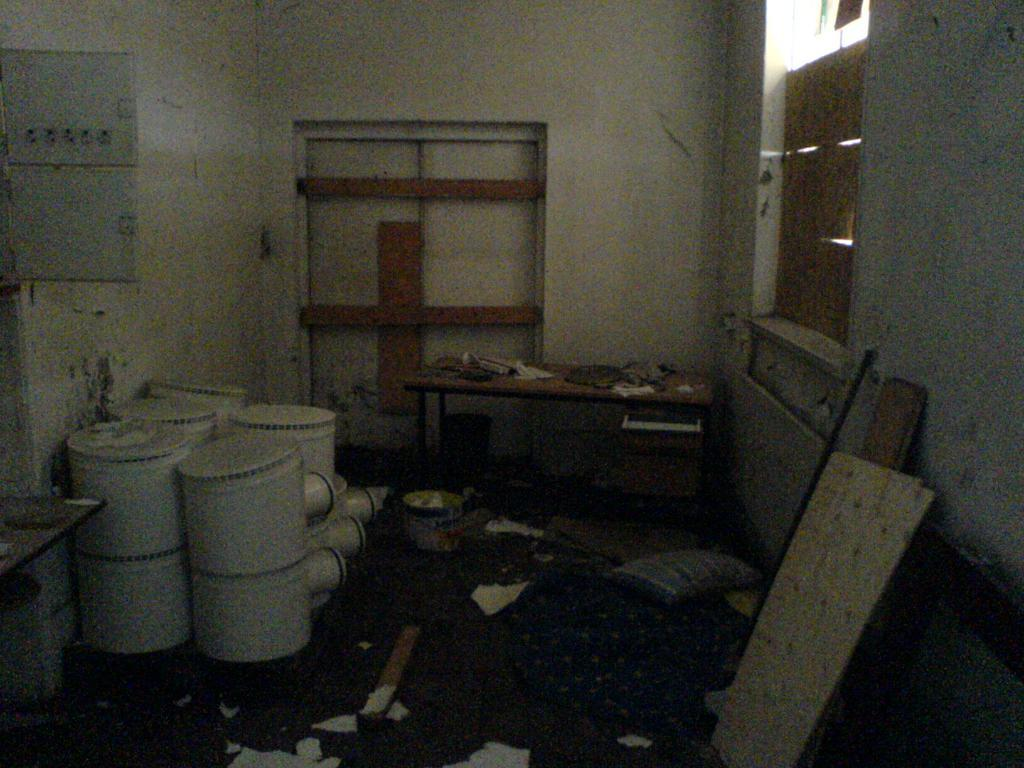What type of objects can be seen stacked in the image? There are boxes in the image. What type of furniture is present in the image? There are tables in the image. What material is used for the planks in the image? There are wooden planks in the image. What type of soft furnishing is visible in the image? There is a pillow in the image. What is on the floor in the image? There are papers on the floor in the image. What type of bat can be seen flying around the church in the image? There is no bat or church present in the image; it features boxes, tables, wooden planks, a pillow, and papers on the floor. 